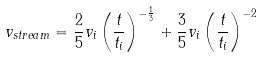Convert formula to latex. <formula><loc_0><loc_0><loc_500><loc_500>v _ { s t r e a m } = \frac { 2 } { 5 } v _ { i } \left ( \frac { t } { t _ { i } } \right ) ^ { - \frac { 1 } { 3 } } + \frac { 3 } { 5 } v _ { i } \left ( \frac { t } { t _ { i } } \right ) ^ { - 2 }</formula> 